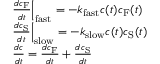Convert formula to latex. <formula><loc_0><loc_0><loc_500><loc_500>\begin{array} { r l } & { \frac { d c _ { F } } { d t } \left | _ { f a s t } = - k _ { f a s t } c ( t ) c _ { F } ( t ) } \\ & { \frac { d c _ { S } } { d t } \right | _ { s l o w } = - k _ { s l o w } c ( t ) c _ { S } ( t ) } \\ & { \frac { d c } { d t } = \frac { d c _ { F } } { d t } + \frac { d c _ { S } } { d t } } \end{array}</formula> 